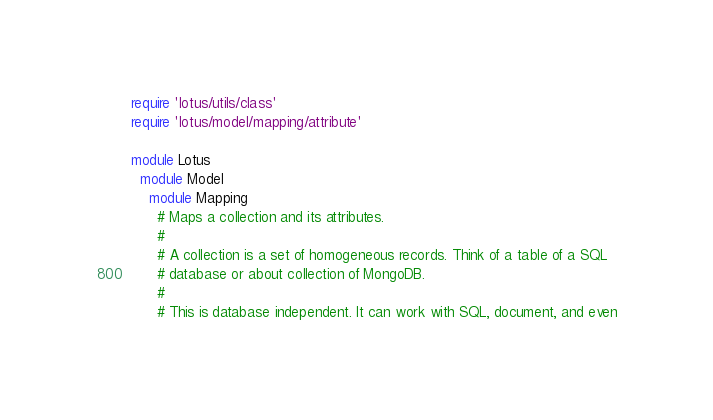<code> <loc_0><loc_0><loc_500><loc_500><_Ruby_>require 'lotus/utils/class'
require 'lotus/model/mapping/attribute'

module Lotus
  module Model
    module Mapping
      # Maps a collection and its attributes.
      #
      # A collection is a set of homogeneous records. Think of a table of a SQL
      # database or about collection of MongoDB.
      #
      # This is database independent. It can work with SQL, document, and even</code> 